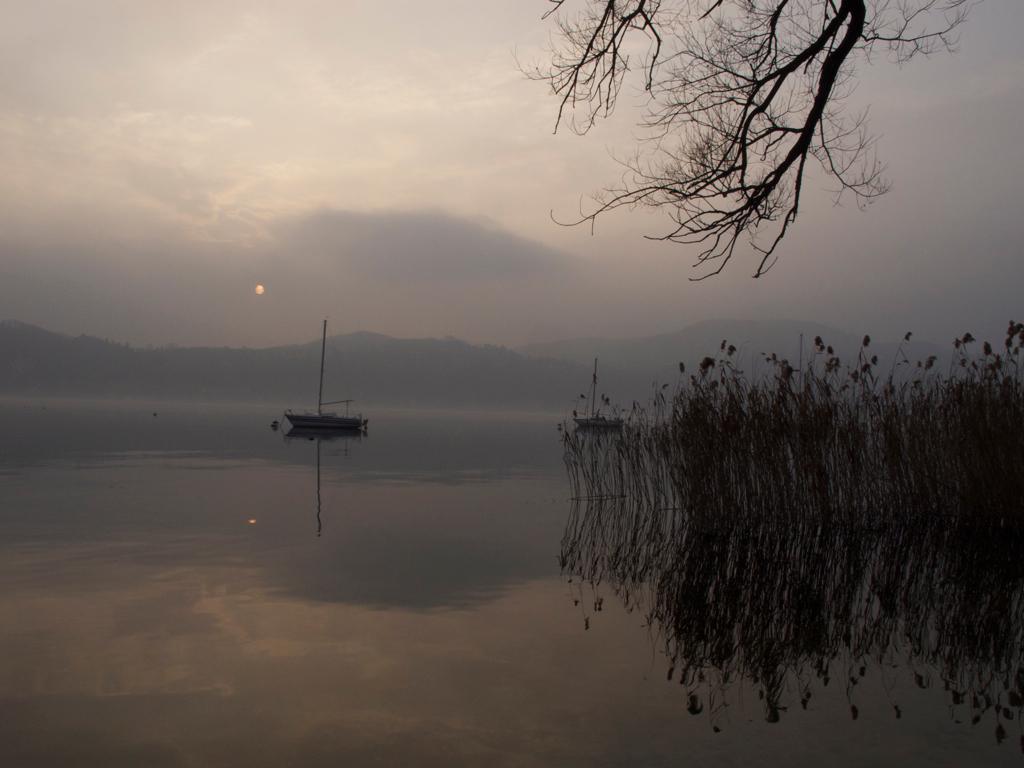Describe this image in one or two sentences. The picture consists of a water body, in the water there are plants and a boat. At the top there are branches of a tree. In the background it is hill covered with trees. Sky is cloudy. In the background it is sun. 